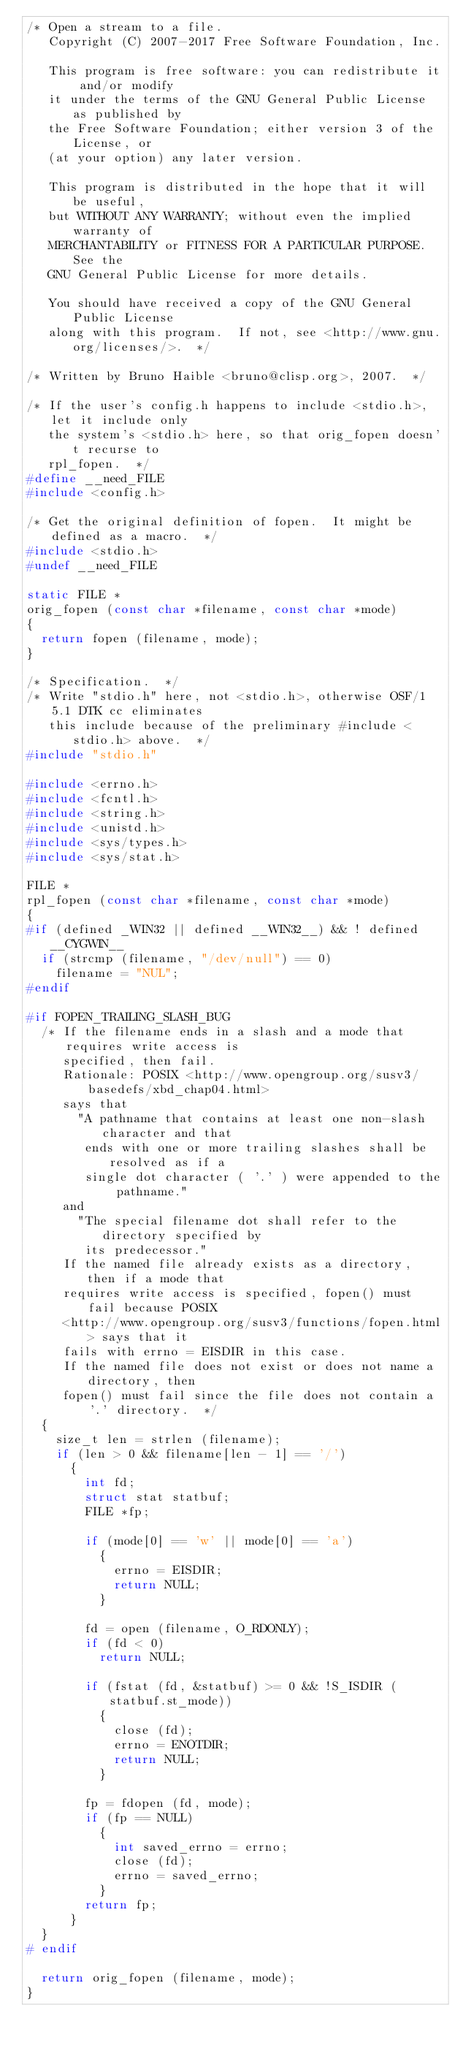Convert code to text. <code><loc_0><loc_0><loc_500><loc_500><_C_>/* Open a stream to a file.
   Copyright (C) 2007-2017 Free Software Foundation, Inc.

   This program is free software: you can redistribute it and/or modify
   it under the terms of the GNU General Public License as published by
   the Free Software Foundation; either version 3 of the License, or
   (at your option) any later version.

   This program is distributed in the hope that it will be useful,
   but WITHOUT ANY WARRANTY; without even the implied warranty of
   MERCHANTABILITY or FITNESS FOR A PARTICULAR PURPOSE.  See the
   GNU General Public License for more details.

   You should have received a copy of the GNU General Public License
   along with this program.  If not, see <http://www.gnu.org/licenses/>.  */

/* Written by Bruno Haible <bruno@clisp.org>, 2007.  */

/* If the user's config.h happens to include <stdio.h>, let it include only
   the system's <stdio.h> here, so that orig_fopen doesn't recurse to
   rpl_fopen.  */
#define __need_FILE
#include <config.h>

/* Get the original definition of fopen.  It might be defined as a macro.  */
#include <stdio.h>
#undef __need_FILE

static FILE *
orig_fopen (const char *filename, const char *mode)
{
  return fopen (filename, mode);
}

/* Specification.  */
/* Write "stdio.h" here, not <stdio.h>, otherwise OSF/1 5.1 DTK cc eliminates
   this include because of the preliminary #include <stdio.h> above.  */
#include "stdio.h"

#include <errno.h>
#include <fcntl.h>
#include <string.h>
#include <unistd.h>
#include <sys/types.h>
#include <sys/stat.h>

FILE *
rpl_fopen (const char *filename, const char *mode)
{
#if (defined _WIN32 || defined __WIN32__) && ! defined __CYGWIN__
  if (strcmp (filename, "/dev/null") == 0)
    filename = "NUL";
#endif

#if FOPEN_TRAILING_SLASH_BUG
  /* If the filename ends in a slash and a mode that requires write access is
     specified, then fail.
     Rationale: POSIX <http://www.opengroup.org/susv3/basedefs/xbd_chap04.html>
     says that
       "A pathname that contains at least one non-slash character and that
        ends with one or more trailing slashes shall be resolved as if a
        single dot character ( '.' ) were appended to the pathname."
     and
       "The special filename dot shall refer to the directory specified by
        its predecessor."
     If the named file already exists as a directory, then if a mode that
     requires write access is specified, fopen() must fail because POSIX
     <http://www.opengroup.org/susv3/functions/fopen.html> says that it
     fails with errno = EISDIR in this case.
     If the named file does not exist or does not name a directory, then
     fopen() must fail since the file does not contain a '.' directory.  */
  {
    size_t len = strlen (filename);
    if (len > 0 && filename[len - 1] == '/')
      {
        int fd;
        struct stat statbuf;
        FILE *fp;

        if (mode[0] == 'w' || mode[0] == 'a')
          {
            errno = EISDIR;
            return NULL;
          }

        fd = open (filename, O_RDONLY);
        if (fd < 0)
          return NULL;

        if (fstat (fd, &statbuf) >= 0 && !S_ISDIR (statbuf.st_mode))
          {
            close (fd);
            errno = ENOTDIR;
            return NULL;
          }

        fp = fdopen (fd, mode);
        if (fp == NULL)
          {
            int saved_errno = errno;
            close (fd);
            errno = saved_errno;
          }
        return fp;
      }
  }
# endif

  return orig_fopen (filename, mode);
}
</code> 